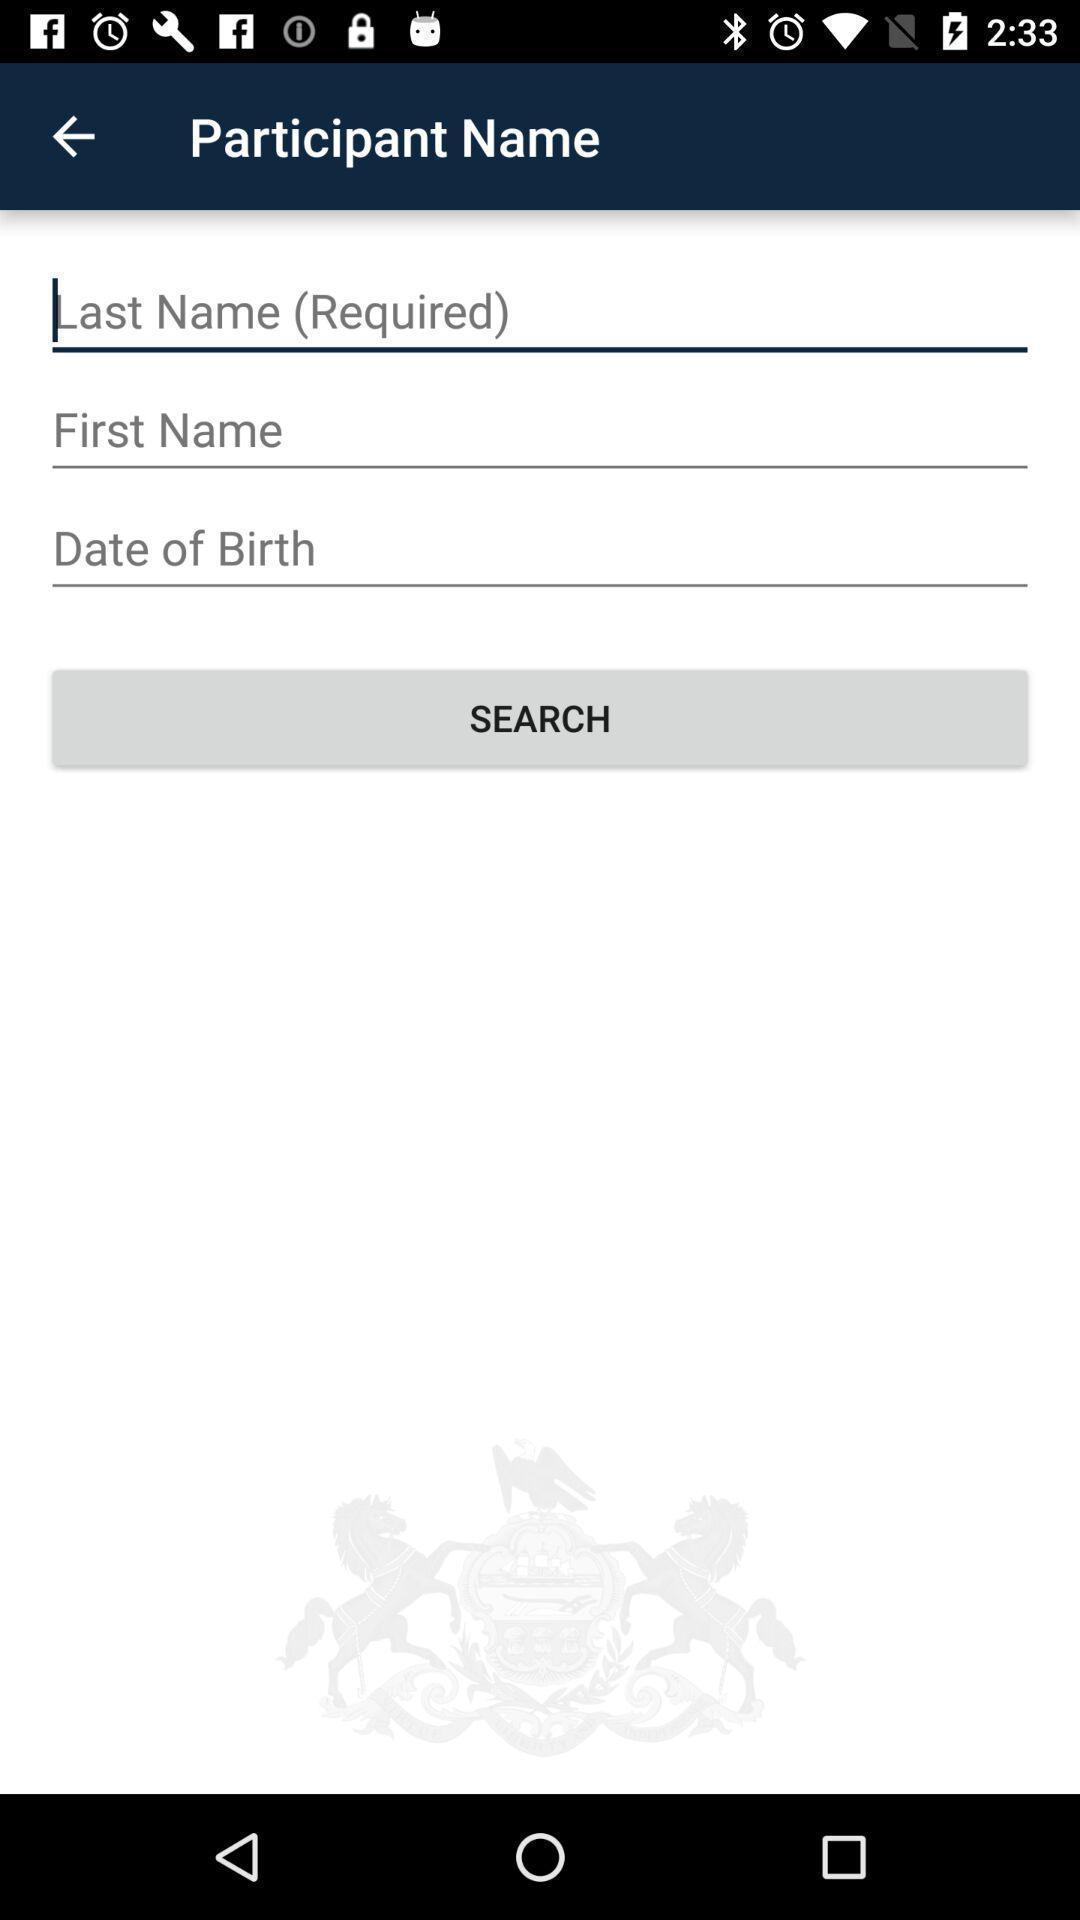Give me a narrative description of this picture. Page showing to enter participant name. 